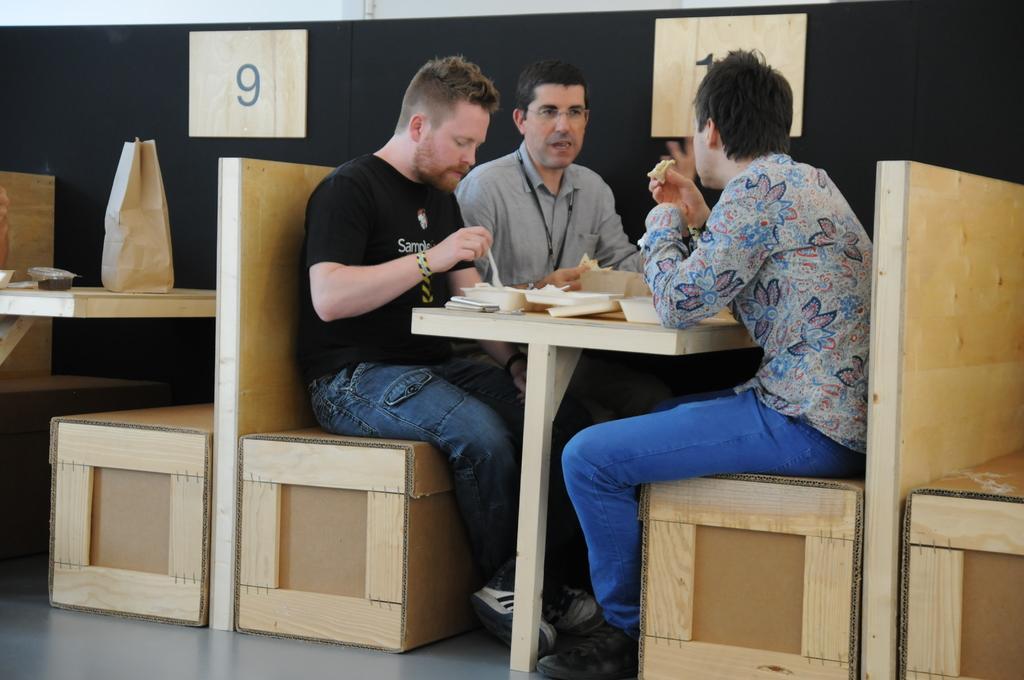In one or two sentences, can you explain what this image depicts? This picture consists of three men sat on either sides of table and having food, this seems to be in a hotel. 